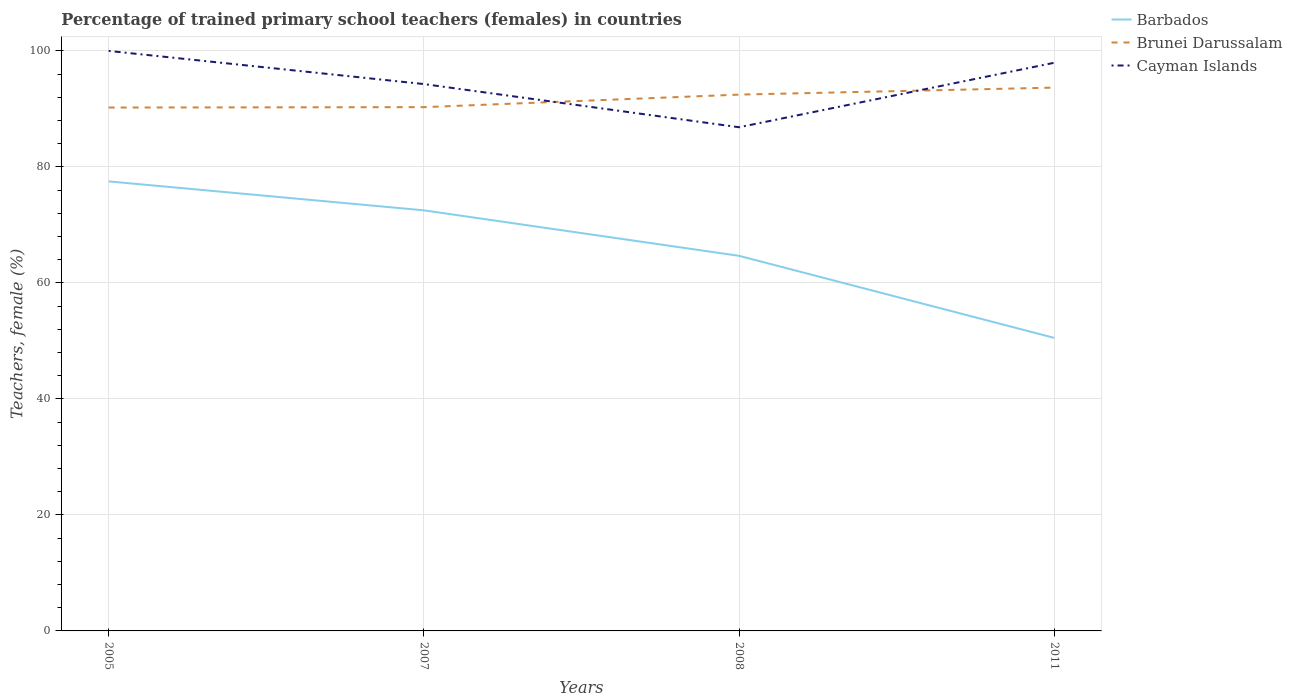How many different coloured lines are there?
Your answer should be very brief. 3. Across all years, what is the maximum percentage of trained primary school teachers (females) in Cayman Islands?
Offer a terse response. 86.84. What is the total percentage of trained primary school teachers (females) in Barbados in the graph?
Your response must be concise. 14.15. What is the difference between the highest and the second highest percentage of trained primary school teachers (females) in Cayman Islands?
Your answer should be very brief. 13.16. What is the difference between the highest and the lowest percentage of trained primary school teachers (females) in Cayman Islands?
Your response must be concise. 2. Is the percentage of trained primary school teachers (females) in Cayman Islands strictly greater than the percentage of trained primary school teachers (females) in Brunei Darussalam over the years?
Give a very brief answer. No. How many lines are there?
Offer a very short reply. 3. How many years are there in the graph?
Offer a very short reply. 4. What is the difference between two consecutive major ticks on the Y-axis?
Your answer should be very brief. 20. Are the values on the major ticks of Y-axis written in scientific E-notation?
Ensure brevity in your answer.  No. Where does the legend appear in the graph?
Offer a terse response. Top right. How many legend labels are there?
Provide a succinct answer. 3. What is the title of the graph?
Provide a short and direct response. Percentage of trained primary school teachers (females) in countries. What is the label or title of the Y-axis?
Keep it short and to the point. Teachers, female (%). What is the Teachers, female (%) in Barbados in 2005?
Offer a very short reply. 77.51. What is the Teachers, female (%) in Brunei Darussalam in 2005?
Provide a succinct answer. 90.24. What is the Teachers, female (%) of Barbados in 2007?
Keep it short and to the point. 72.51. What is the Teachers, female (%) in Brunei Darussalam in 2007?
Provide a short and direct response. 90.31. What is the Teachers, female (%) in Cayman Islands in 2007?
Your answer should be compact. 94.29. What is the Teachers, female (%) in Barbados in 2008?
Offer a terse response. 64.67. What is the Teachers, female (%) of Brunei Darussalam in 2008?
Make the answer very short. 92.47. What is the Teachers, female (%) of Cayman Islands in 2008?
Provide a short and direct response. 86.84. What is the Teachers, female (%) in Barbados in 2011?
Your answer should be compact. 50.52. What is the Teachers, female (%) in Brunei Darussalam in 2011?
Offer a terse response. 93.68. What is the Teachers, female (%) in Cayman Islands in 2011?
Offer a very short reply. 97.96. Across all years, what is the maximum Teachers, female (%) of Barbados?
Your response must be concise. 77.51. Across all years, what is the maximum Teachers, female (%) of Brunei Darussalam?
Offer a very short reply. 93.68. Across all years, what is the minimum Teachers, female (%) in Barbados?
Your answer should be compact. 50.52. Across all years, what is the minimum Teachers, female (%) of Brunei Darussalam?
Offer a terse response. 90.24. Across all years, what is the minimum Teachers, female (%) of Cayman Islands?
Offer a very short reply. 86.84. What is the total Teachers, female (%) in Barbados in the graph?
Your answer should be compact. 265.22. What is the total Teachers, female (%) in Brunei Darussalam in the graph?
Your answer should be very brief. 366.69. What is the total Teachers, female (%) of Cayman Islands in the graph?
Give a very brief answer. 379.09. What is the difference between the Teachers, female (%) of Barbados in 2005 and that in 2007?
Ensure brevity in your answer.  4.99. What is the difference between the Teachers, female (%) of Brunei Darussalam in 2005 and that in 2007?
Give a very brief answer. -0.07. What is the difference between the Teachers, female (%) of Cayman Islands in 2005 and that in 2007?
Provide a short and direct response. 5.71. What is the difference between the Teachers, female (%) in Barbados in 2005 and that in 2008?
Offer a very short reply. 12.84. What is the difference between the Teachers, female (%) in Brunei Darussalam in 2005 and that in 2008?
Ensure brevity in your answer.  -2.23. What is the difference between the Teachers, female (%) of Cayman Islands in 2005 and that in 2008?
Offer a terse response. 13.16. What is the difference between the Teachers, female (%) in Barbados in 2005 and that in 2011?
Provide a short and direct response. 26.98. What is the difference between the Teachers, female (%) of Brunei Darussalam in 2005 and that in 2011?
Provide a short and direct response. -3.44. What is the difference between the Teachers, female (%) of Cayman Islands in 2005 and that in 2011?
Your response must be concise. 2.04. What is the difference between the Teachers, female (%) in Barbados in 2007 and that in 2008?
Your answer should be very brief. 7.84. What is the difference between the Teachers, female (%) of Brunei Darussalam in 2007 and that in 2008?
Provide a succinct answer. -2.16. What is the difference between the Teachers, female (%) in Cayman Islands in 2007 and that in 2008?
Your response must be concise. 7.44. What is the difference between the Teachers, female (%) of Barbados in 2007 and that in 2011?
Your answer should be compact. 21.99. What is the difference between the Teachers, female (%) of Brunei Darussalam in 2007 and that in 2011?
Ensure brevity in your answer.  -3.37. What is the difference between the Teachers, female (%) of Cayman Islands in 2007 and that in 2011?
Make the answer very short. -3.67. What is the difference between the Teachers, female (%) in Barbados in 2008 and that in 2011?
Provide a succinct answer. 14.15. What is the difference between the Teachers, female (%) in Brunei Darussalam in 2008 and that in 2011?
Offer a very short reply. -1.21. What is the difference between the Teachers, female (%) of Cayman Islands in 2008 and that in 2011?
Offer a terse response. -11.12. What is the difference between the Teachers, female (%) in Barbados in 2005 and the Teachers, female (%) in Brunei Darussalam in 2007?
Your answer should be compact. -12.8. What is the difference between the Teachers, female (%) in Barbados in 2005 and the Teachers, female (%) in Cayman Islands in 2007?
Your answer should be very brief. -16.78. What is the difference between the Teachers, female (%) of Brunei Darussalam in 2005 and the Teachers, female (%) of Cayman Islands in 2007?
Offer a terse response. -4.05. What is the difference between the Teachers, female (%) in Barbados in 2005 and the Teachers, female (%) in Brunei Darussalam in 2008?
Make the answer very short. -14.96. What is the difference between the Teachers, female (%) in Barbados in 2005 and the Teachers, female (%) in Cayman Islands in 2008?
Offer a terse response. -9.33. What is the difference between the Teachers, female (%) in Brunei Darussalam in 2005 and the Teachers, female (%) in Cayman Islands in 2008?
Your response must be concise. 3.39. What is the difference between the Teachers, female (%) in Barbados in 2005 and the Teachers, female (%) in Brunei Darussalam in 2011?
Your response must be concise. -16.17. What is the difference between the Teachers, female (%) in Barbados in 2005 and the Teachers, female (%) in Cayman Islands in 2011?
Your answer should be compact. -20.45. What is the difference between the Teachers, female (%) of Brunei Darussalam in 2005 and the Teachers, female (%) of Cayman Islands in 2011?
Give a very brief answer. -7.72. What is the difference between the Teachers, female (%) in Barbados in 2007 and the Teachers, female (%) in Brunei Darussalam in 2008?
Keep it short and to the point. -19.95. What is the difference between the Teachers, female (%) of Barbados in 2007 and the Teachers, female (%) of Cayman Islands in 2008?
Offer a terse response. -14.33. What is the difference between the Teachers, female (%) of Brunei Darussalam in 2007 and the Teachers, female (%) of Cayman Islands in 2008?
Provide a succinct answer. 3.46. What is the difference between the Teachers, female (%) in Barbados in 2007 and the Teachers, female (%) in Brunei Darussalam in 2011?
Your answer should be very brief. -21.16. What is the difference between the Teachers, female (%) in Barbados in 2007 and the Teachers, female (%) in Cayman Islands in 2011?
Provide a succinct answer. -25.44. What is the difference between the Teachers, female (%) in Brunei Darussalam in 2007 and the Teachers, female (%) in Cayman Islands in 2011?
Offer a terse response. -7.65. What is the difference between the Teachers, female (%) of Barbados in 2008 and the Teachers, female (%) of Brunei Darussalam in 2011?
Provide a short and direct response. -29. What is the difference between the Teachers, female (%) in Barbados in 2008 and the Teachers, female (%) in Cayman Islands in 2011?
Ensure brevity in your answer.  -33.29. What is the difference between the Teachers, female (%) of Brunei Darussalam in 2008 and the Teachers, female (%) of Cayman Islands in 2011?
Your answer should be very brief. -5.49. What is the average Teachers, female (%) of Barbados per year?
Make the answer very short. 66.3. What is the average Teachers, female (%) of Brunei Darussalam per year?
Give a very brief answer. 91.67. What is the average Teachers, female (%) in Cayman Islands per year?
Your answer should be compact. 94.77. In the year 2005, what is the difference between the Teachers, female (%) in Barbados and Teachers, female (%) in Brunei Darussalam?
Your response must be concise. -12.73. In the year 2005, what is the difference between the Teachers, female (%) in Barbados and Teachers, female (%) in Cayman Islands?
Provide a succinct answer. -22.49. In the year 2005, what is the difference between the Teachers, female (%) of Brunei Darussalam and Teachers, female (%) of Cayman Islands?
Your response must be concise. -9.76. In the year 2007, what is the difference between the Teachers, female (%) in Barbados and Teachers, female (%) in Brunei Darussalam?
Keep it short and to the point. -17.79. In the year 2007, what is the difference between the Teachers, female (%) in Barbados and Teachers, female (%) in Cayman Islands?
Provide a short and direct response. -21.77. In the year 2007, what is the difference between the Teachers, female (%) of Brunei Darussalam and Teachers, female (%) of Cayman Islands?
Offer a terse response. -3.98. In the year 2008, what is the difference between the Teachers, female (%) of Barbados and Teachers, female (%) of Brunei Darussalam?
Provide a succinct answer. -27.79. In the year 2008, what is the difference between the Teachers, female (%) of Barbados and Teachers, female (%) of Cayman Islands?
Offer a very short reply. -22.17. In the year 2008, what is the difference between the Teachers, female (%) of Brunei Darussalam and Teachers, female (%) of Cayman Islands?
Offer a terse response. 5.63. In the year 2011, what is the difference between the Teachers, female (%) in Barbados and Teachers, female (%) in Brunei Darussalam?
Provide a succinct answer. -43.15. In the year 2011, what is the difference between the Teachers, female (%) of Barbados and Teachers, female (%) of Cayman Islands?
Keep it short and to the point. -47.44. In the year 2011, what is the difference between the Teachers, female (%) in Brunei Darussalam and Teachers, female (%) in Cayman Islands?
Ensure brevity in your answer.  -4.28. What is the ratio of the Teachers, female (%) of Barbados in 2005 to that in 2007?
Provide a short and direct response. 1.07. What is the ratio of the Teachers, female (%) in Cayman Islands in 2005 to that in 2007?
Offer a very short reply. 1.06. What is the ratio of the Teachers, female (%) of Barbados in 2005 to that in 2008?
Your answer should be very brief. 1.2. What is the ratio of the Teachers, female (%) in Brunei Darussalam in 2005 to that in 2008?
Ensure brevity in your answer.  0.98. What is the ratio of the Teachers, female (%) of Cayman Islands in 2005 to that in 2008?
Your response must be concise. 1.15. What is the ratio of the Teachers, female (%) of Barbados in 2005 to that in 2011?
Your answer should be compact. 1.53. What is the ratio of the Teachers, female (%) in Brunei Darussalam in 2005 to that in 2011?
Your response must be concise. 0.96. What is the ratio of the Teachers, female (%) in Cayman Islands in 2005 to that in 2011?
Your answer should be very brief. 1.02. What is the ratio of the Teachers, female (%) in Barbados in 2007 to that in 2008?
Keep it short and to the point. 1.12. What is the ratio of the Teachers, female (%) in Brunei Darussalam in 2007 to that in 2008?
Your response must be concise. 0.98. What is the ratio of the Teachers, female (%) in Cayman Islands in 2007 to that in 2008?
Ensure brevity in your answer.  1.09. What is the ratio of the Teachers, female (%) in Barbados in 2007 to that in 2011?
Keep it short and to the point. 1.44. What is the ratio of the Teachers, female (%) in Cayman Islands in 2007 to that in 2011?
Make the answer very short. 0.96. What is the ratio of the Teachers, female (%) of Barbados in 2008 to that in 2011?
Your answer should be compact. 1.28. What is the ratio of the Teachers, female (%) in Brunei Darussalam in 2008 to that in 2011?
Ensure brevity in your answer.  0.99. What is the ratio of the Teachers, female (%) of Cayman Islands in 2008 to that in 2011?
Give a very brief answer. 0.89. What is the difference between the highest and the second highest Teachers, female (%) of Barbados?
Make the answer very short. 4.99. What is the difference between the highest and the second highest Teachers, female (%) in Brunei Darussalam?
Ensure brevity in your answer.  1.21. What is the difference between the highest and the second highest Teachers, female (%) of Cayman Islands?
Provide a short and direct response. 2.04. What is the difference between the highest and the lowest Teachers, female (%) in Barbados?
Make the answer very short. 26.98. What is the difference between the highest and the lowest Teachers, female (%) in Brunei Darussalam?
Your answer should be very brief. 3.44. What is the difference between the highest and the lowest Teachers, female (%) in Cayman Islands?
Offer a very short reply. 13.16. 